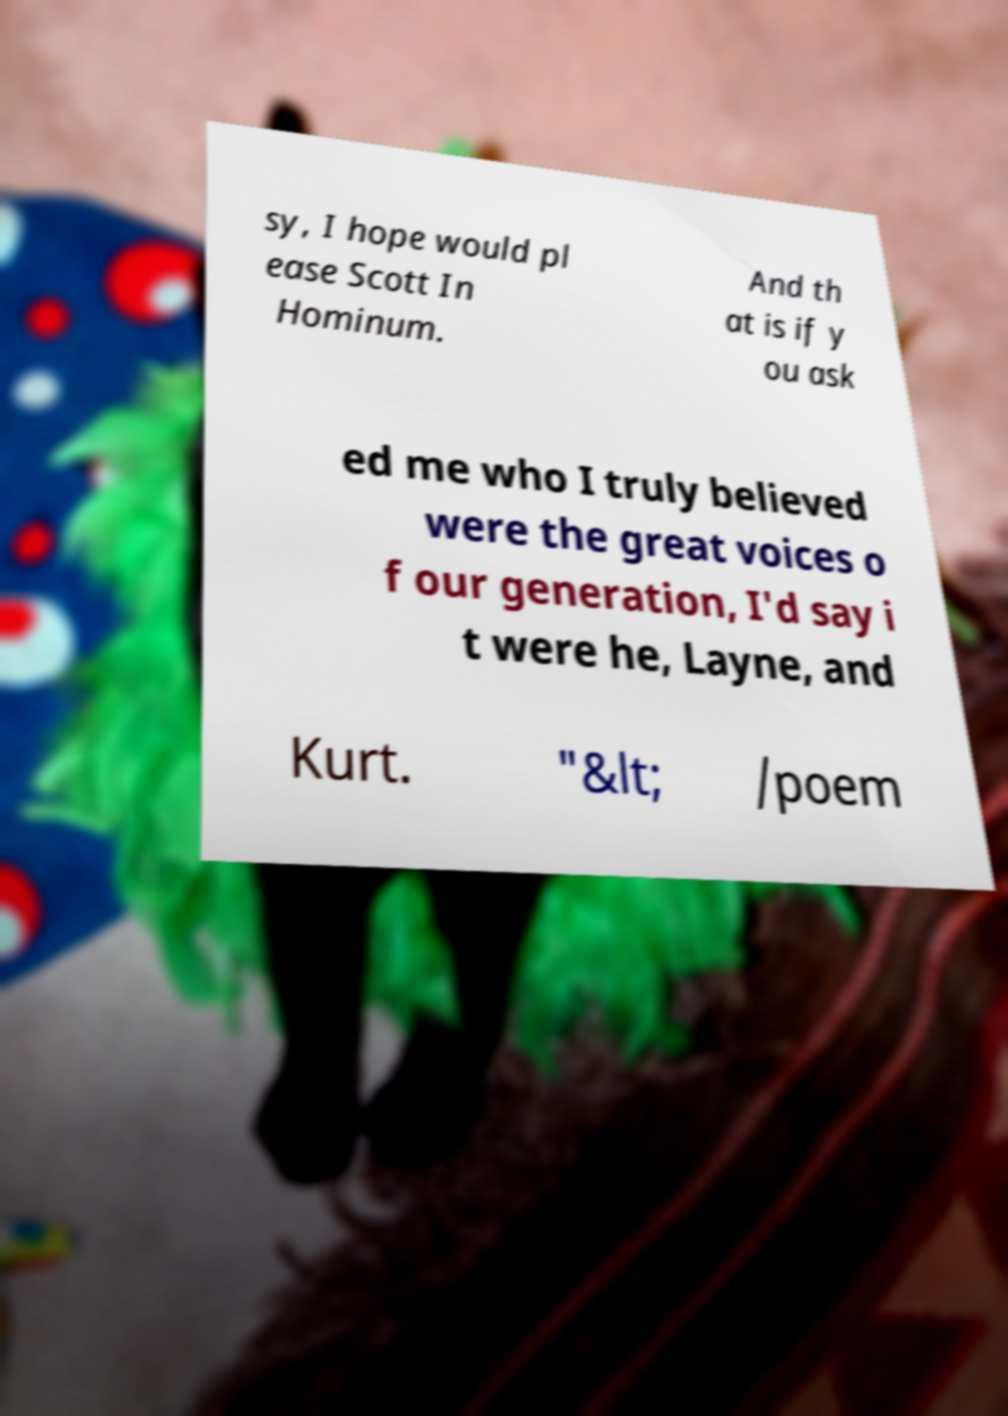Can you read and provide the text displayed in the image?This photo seems to have some interesting text. Can you extract and type it out for me? sy, I hope would pl ease Scott In Hominum. And th at is if y ou ask ed me who I truly believed were the great voices o f our generation, I'd say i t were he, Layne, and Kurt. "&lt; /poem 